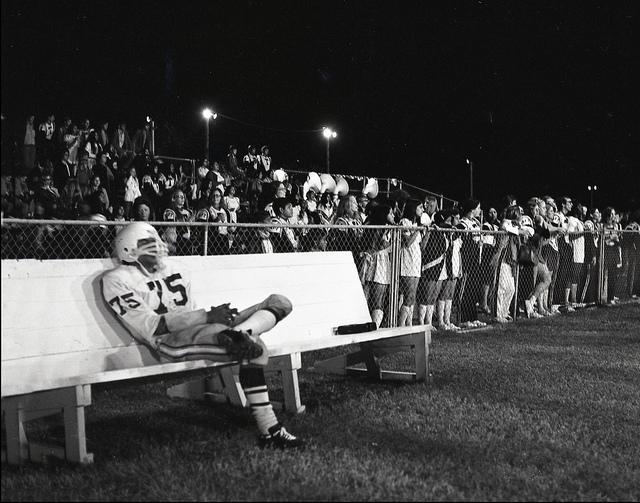Is he playing baseball?
Give a very brief answer. No. What are the people standing in front of?
Quick response, please. Fence. What is on the man's head?
Keep it brief. Helmet. What sport does the player sitting on the bench play?
Give a very brief answer. Football. What is in his mouth?
Concise answer only. Mouthguard. What is the number on the man's Jersey?
Quick response, please. 75. How many people are sitting on the bench?
Concise answer only. 1. What is in the man's lap?
Short answer required. Hands. What sport are they doing?
Write a very short answer. Football. Why are these people sitting outside?
Quick response, please. Watching football. 